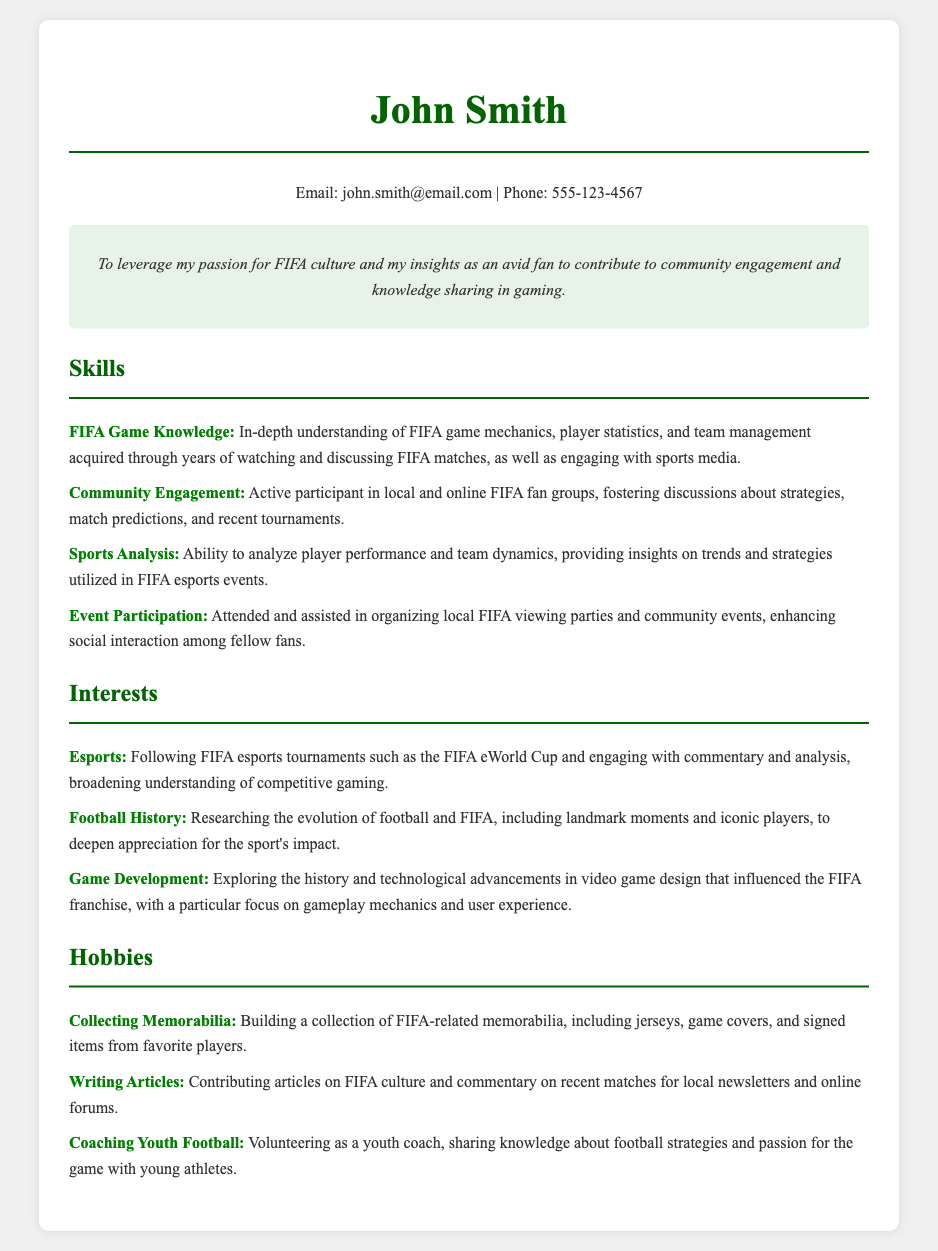What is the name of the individual? The name listed at the top of the resume is John Smith.
Answer: John Smith What is the email address provided? The resume includes a contact email for John Smith as john.smith@email.com.
Answer: john.smith@email.com How many skills are listed in the Skills section? There are a total of four distinct skills described under the Skills section.
Answer: 4 What is one of the listed interests related to competitive gaming? One interest mentioned is following FIFA esports tournaments such as the FIFA eWorld Cup.
Answer: Esports What hobby involves working with young athletes? The hobby described that involves young athletes is coaching youth football.
Answer: Coaching Youth Football What is the objective of the resume? The objective clearly states the desire to leverage passion for FIFA culture for community engagement.
Answer: To leverage my passion for FIFA culture In what context does John Smith engage in community activities? John Smith participates in organizing events such as FIFA viewing parties to enhance social interaction.
Answer: Organizing local FIFA viewing parties What specific memorabilia does John Smith collect? John Smith builds a collection of FIFA-related items, including jerseys and signed items.
Answer: FIFA-related memorabilia What reason does John Smith have for researching football history? The purpose is to deepen appreciation for the sport's impact through landmark moments and players.
Answer: Deepen appreciation for the sport's impact 